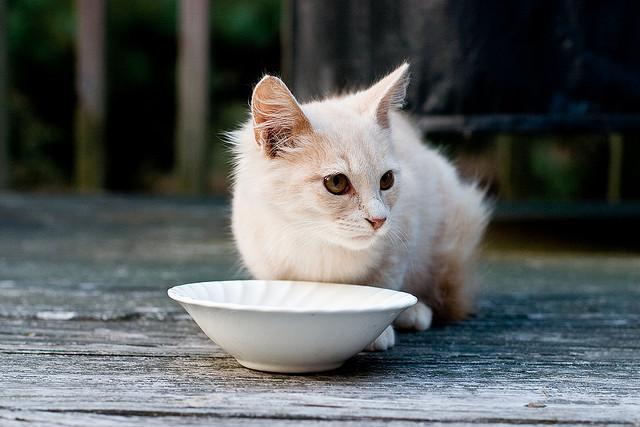How many people are behind the fence?
Give a very brief answer. 0. 